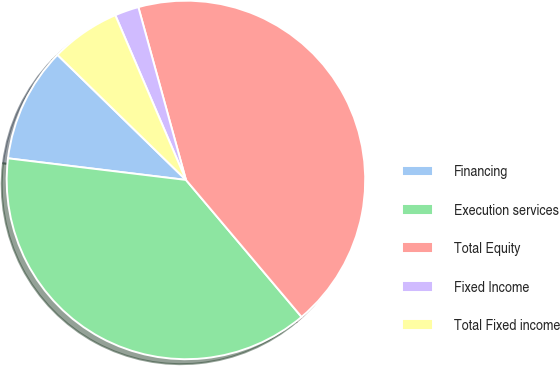<chart> <loc_0><loc_0><loc_500><loc_500><pie_chart><fcel>Financing<fcel>Execution services<fcel>Total Equity<fcel>Fixed Income<fcel>Total Fixed income<nl><fcel>10.36%<fcel>38.08%<fcel>43.12%<fcel>2.17%<fcel>6.27%<nl></chart> 